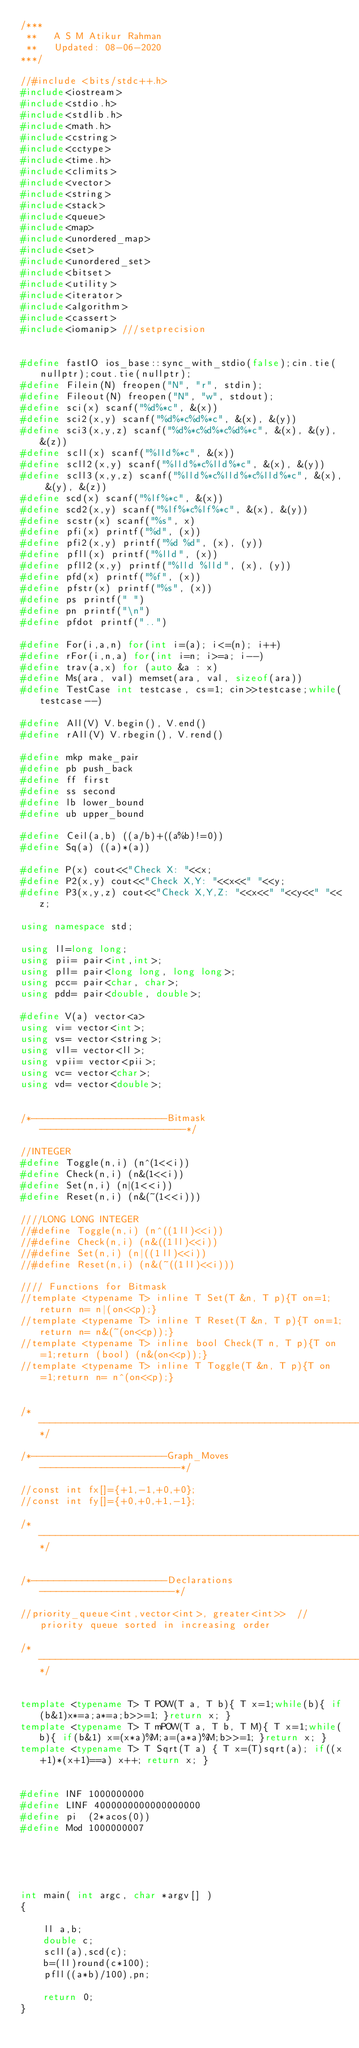Convert code to text. <code><loc_0><loc_0><loc_500><loc_500><_C++_>/***
 **   A S M Atikur Rahman
 **   Updated: 08-06-2020
***/

//#include <bits/stdc++.h>
#include<iostream>
#include<stdio.h>
#include<stdlib.h>
#include<math.h>
#include<cstring>
#include<cctype>
#include<time.h>
#include<climits>
#include<vector>
#include<string>
#include<stack>
#include<queue>
#include<map>
#include<unordered_map>
#include<set>
#include<unordered_set>
#include<bitset>
#include<utility>
#include<iterator>
#include<algorithm>
#include<cassert>
#include<iomanip> ///setprecision


#define fastIO ios_base::sync_with_stdio(false);cin.tie(nullptr);cout.tie(nullptr);
#define Filein(N) freopen("N", "r", stdin);
#define Fileout(N) freopen("N", "w", stdout);
#define sci(x) scanf("%d%*c", &(x))
#define sci2(x,y) scanf("%d%*c%d%*c", &(x), &(y))
#define sci3(x,y,z) scanf("%d%*c%d%*c%d%*c", &(x), &(y), &(z))
#define scll(x) scanf("%lld%*c", &(x))
#define scll2(x,y) scanf("%lld%*c%lld%*c", &(x), &(y))
#define scll3(x,y,z) scanf("%lld%*c%lld%*c%lld%*c", &(x), &(y), &(z))
#define scd(x) scanf("%lf%*c", &(x))
#define scd2(x,y) scanf("%lf%*c%lf%*c", &(x), &(y))
#define scstr(x) scanf("%s", x)
#define pfi(x) printf("%d", (x))
#define pfi2(x,y) printf("%d %d", (x), (y))
#define pfll(x) printf("%lld", (x))
#define pfll2(x,y) printf("%lld %lld", (x), (y))
#define pfd(x) printf("%f", (x))
#define pfstr(x) printf("%s", (x))
#define ps printf(" ")
#define pn printf("\n")
#define pfdot printf("..")

#define For(i,a,n) for(int i=(a); i<=(n); i++)
#define rFor(i,n,a) for(int i=n; i>=a; i--)
#define trav(a,x) for (auto &a : x)
#define Ms(ara, val) memset(ara, val, sizeof(ara))
#define TestCase int testcase, cs=1; cin>>testcase;while(testcase--)

#define All(V) V.begin(), V.end()
#define rAll(V) V.rbegin(), V.rend()

#define mkp make_pair
#define pb push_back
#define ff first
#define ss second
#define lb lower_bound
#define ub upper_bound

#define Ceil(a,b) ((a/b)+((a%b)!=0))
#define Sq(a) ((a)*(a))

#define P(x) cout<<"Check X: "<<x;
#define P2(x,y) cout<<"Check X,Y: "<<x<<" "<<y;
#define P3(x,y,z) cout<<"Check X,Y,Z: "<<x<<" "<<y<<" "<<z;

using namespace std;

using ll=long long;
using pii= pair<int,int>;
using pll= pair<long long, long long>;
using pcc= pair<char, char>;
using pdd= pair<double, double>;

#define V(a) vector<a>
using vi= vector<int>;
using vs= vector<string>;
using vll= vector<ll>;
using vpii= vector<pii>;
using vc= vector<char>;
using vd= vector<double>;


/*------------------------Bitmask--------------------------*/

//INTEGER
#define Toggle(n,i) (n^(1<<i))
#define Check(n,i) (n&(1<<i))
#define Set(n,i) (n|(1<<i))
#define Reset(n,i) (n&(~(1<<i)))

////LONG LONG INTEGER
//#define Toggle(n,i) (n^((1ll)<<i))
//#define Check(n,i) (n&((1ll)<<i))
//#define Set(n,i) (n|((1ll)<<i))
//#define Reset(n,i) (n&(~((1ll)<<i)))

//// Functions for Bitmask
//template <typename T> inline T Set(T &n, T p){T on=1;return n= n|(on<<p);}
//template <typename T> inline T Reset(T &n, T p){T on=1;return n= n&(~(on<<p));}
//template <typename T> inline bool Check(T n, T p){T on=1;return (bool) (n&(on<<p));}
//template <typename T> inline T Toggle(T &n, T p){T on=1;return n= n^(on<<p);}


/*----------------------------------------------------------*/

/*------------------------Graph_Moves-------------------------*/

//const int fx[]={+1,-1,+0,+0};
//const int fy[]={+0,+0,+1,-1};

/*------------------------------------------------------------*/


/*------------------------Declarations------------------------*/

//priority_queue<int,vector<int>, greater<int>>  //priority queue sorted in increasing order

/*------------------------------------------------------------*/


template <typename T> T POW(T a, T b){ T x=1;while(b){ if(b&1)x*=a;a*=a;b>>=1; }return x; }
template <typename T> T mPOW(T a, T b, T M){ T x=1;while(b){ if(b&1) x=(x*a)%M;a=(a*a)%M;b>>=1; }return x; }
template <typename T> T Sqrt(T a) { T x=(T)sqrt(a); if((x+1)*(x+1)==a) x++; return x; }


#define INF 1000000000
#define LINF 4000000000000000000
#define pi  (2*acos(0))
#define Mod 1000000007





int main( int argc, char *argv[] )
{

    ll a,b;
    double c;
    scll(a),scd(c);
    b=(ll)round(c*100);
    pfll((a*b)/100),pn;

    return 0;
}

















































</code> 